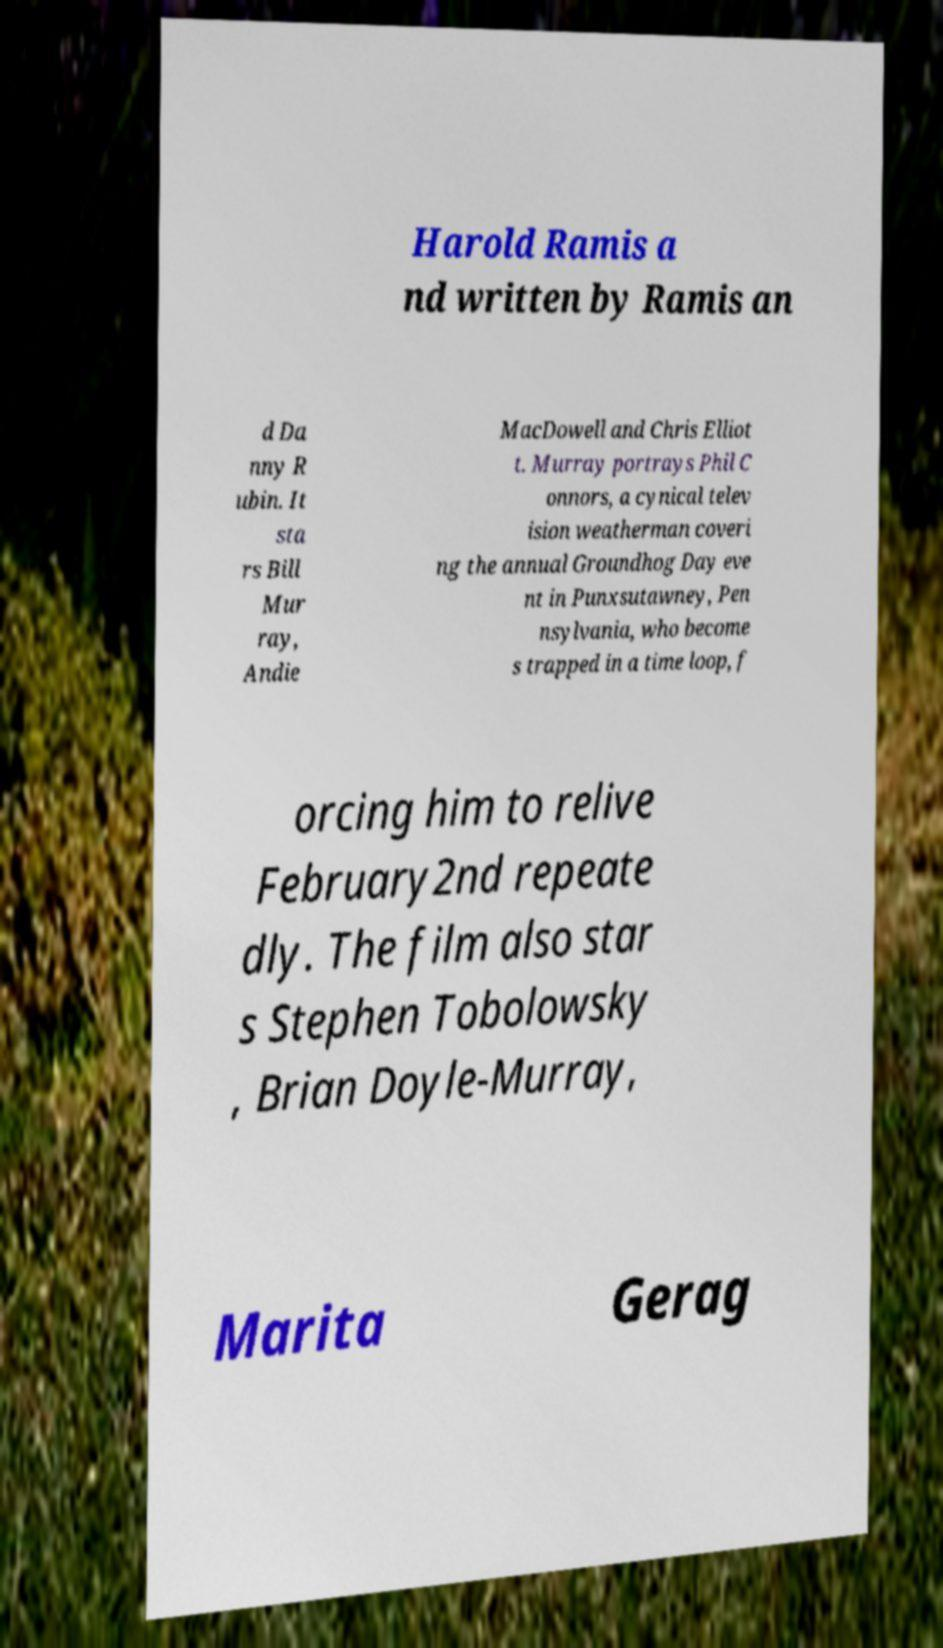Could you extract and type out the text from this image? Harold Ramis a nd written by Ramis an d Da nny R ubin. It sta rs Bill Mur ray, Andie MacDowell and Chris Elliot t. Murray portrays Phil C onnors, a cynical telev ision weatherman coveri ng the annual Groundhog Day eve nt in Punxsutawney, Pen nsylvania, who become s trapped in a time loop, f orcing him to relive February2nd repeate dly. The film also star s Stephen Tobolowsky , Brian Doyle-Murray, Marita Gerag 